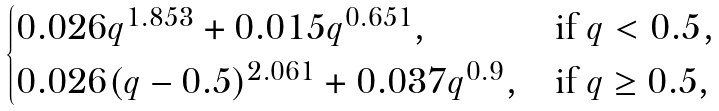<formula> <loc_0><loc_0><loc_500><loc_500>\begin{cases} 0 . 0 2 6 q ^ { 1 . 8 5 3 } + 0 . 0 1 5 q ^ { 0 . 6 5 1 } , & \text {if $q<0.5$} , \\ 0 . 0 2 6 ( q - 0 . 5 ) ^ { 2 . 0 6 1 } + 0 . 0 3 7 q ^ { 0 . 9 } , & \text {if $q\geq 0.5$,} \end{cases}</formula> 